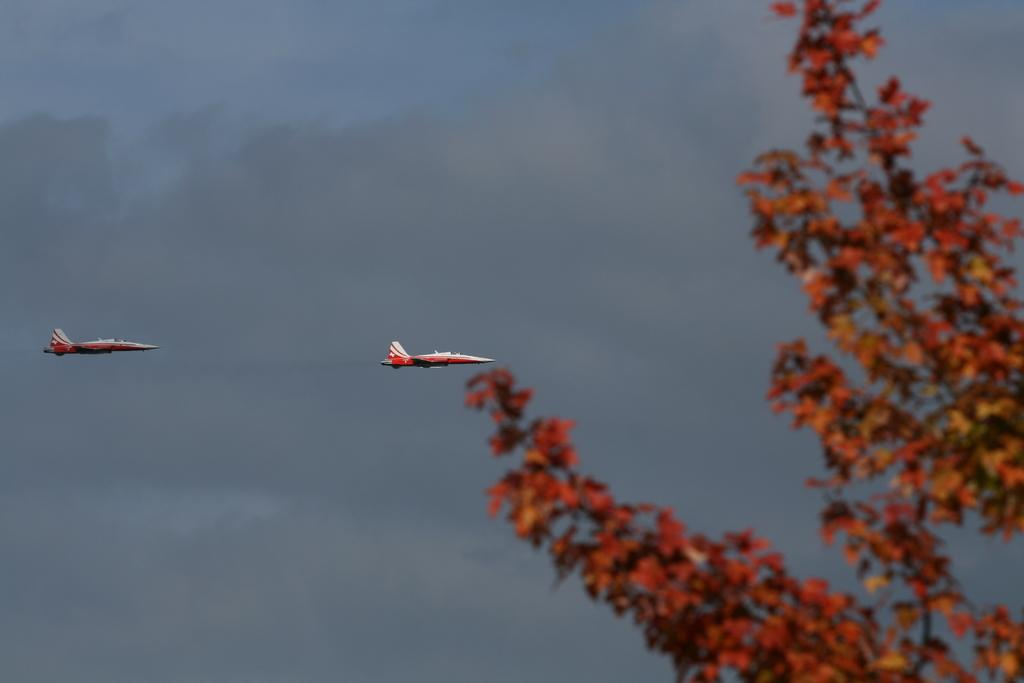What type of vehicles are in the picture? There are jet planes in the picture. What natural element is present in the picture? There is a tree in the picture. How would you describe the weather in the picture? The sky is cloudy in the picture. What type of joke is being told by the hospital in the picture? There is no hospital present in the picture, and therefore no joke can be attributed to it. 